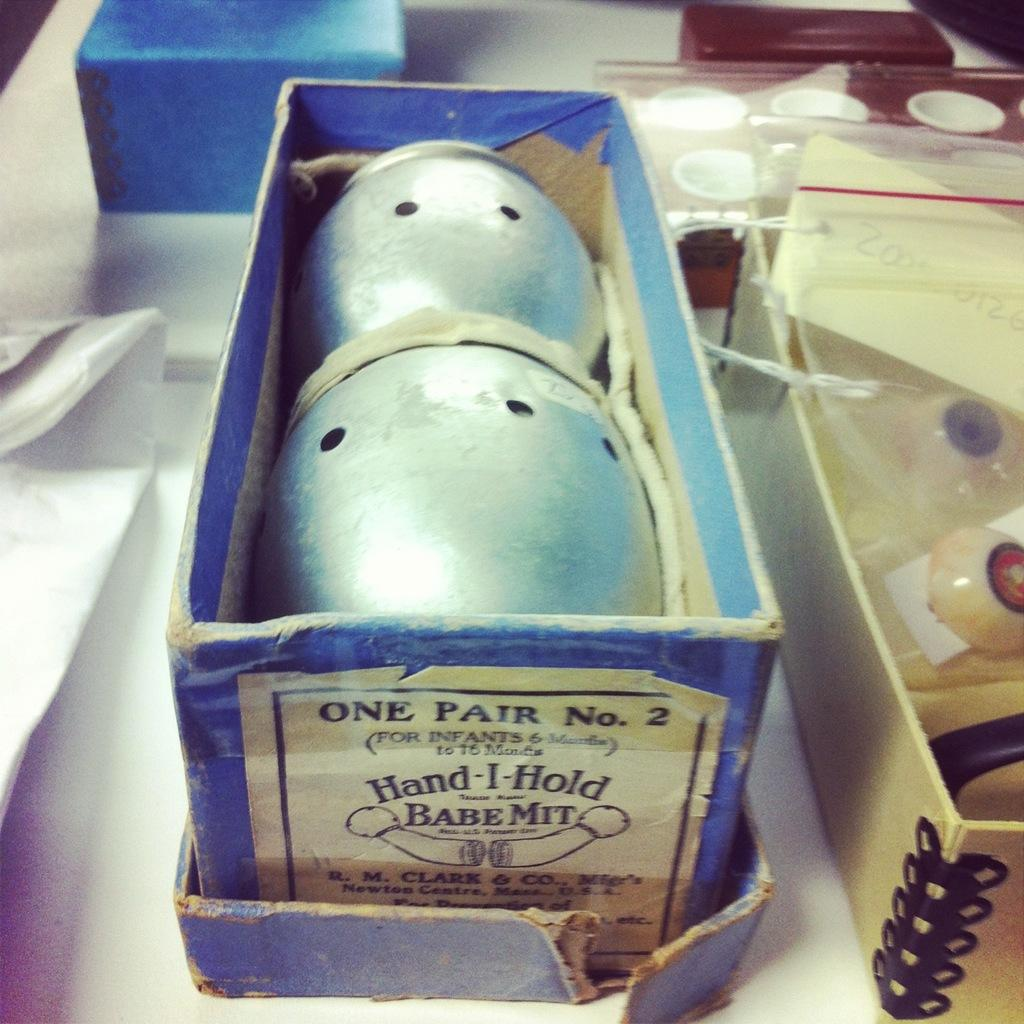What objects are present in the image? There are boxes in the image. Are there any bears or frogs interacting with the boxes in the image? There is no mention of bears or frogs in the image; only boxes are present. 